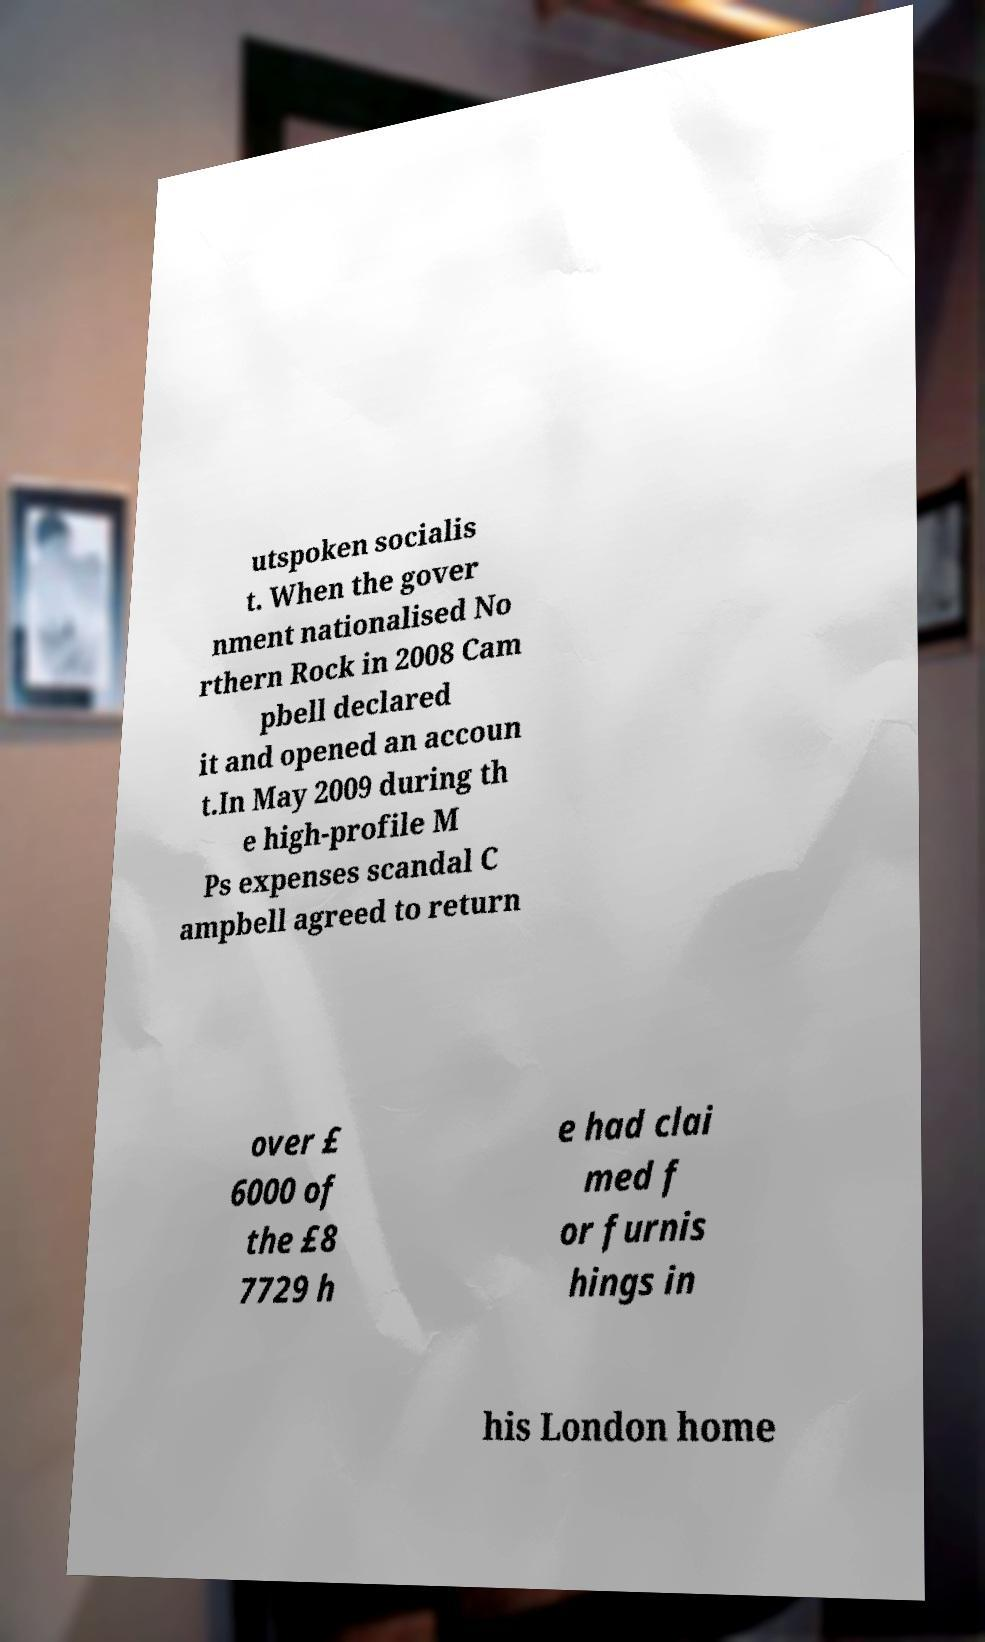Could you extract and type out the text from this image? utspoken socialis t. When the gover nment nationalised No rthern Rock in 2008 Cam pbell declared it and opened an accoun t.In May 2009 during th e high-profile M Ps expenses scandal C ampbell agreed to return over £ 6000 of the £8 7729 h e had clai med f or furnis hings in his London home 